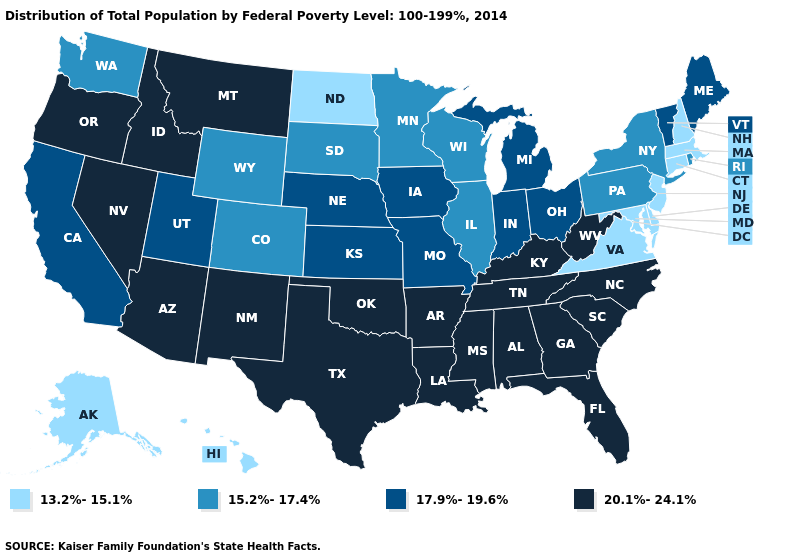What is the value of Illinois?
Short answer required. 15.2%-17.4%. Does Oregon have the highest value in the USA?
Short answer required. Yes. What is the lowest value in the Northeast?
Short answer required. 13.2%-15.1%. Does Florida have a higher value than South Carolina?
Short answer required. No. Does the first symbol in the legend represent the smallest category?
Concise answer only. Yes. What is the highest value in states that border Oregon?
Quick response, please. 20.1%-24.1%. Does Illinois have the lowest value in the USA?
Keep it brief. No. What is the value of Indiana?
Be succinct. 17.9%-19.6%. Name the states that have a value in the range 17.9%-19.6%?
Keep it brief. California, Indiana, Iowa, Kansas, Maine, Michigan, Missouri, Nebraska, Ohio, Utah, Vermont. How many symbols are there in the legend?
Quick response, please. 4. Does Rhode Island have a higher value than Arizona?
Write a very short answer. No. What is the value of Kentucky?
Give a very brief answer. 20.1%-24.1%. How many symbols are there in the legend?
Give a very brief answer. 4. What is the value of Hawaii?
Answer briefly. 13.2%-15.1%. What is the value of North Carolina?
Give a very brief answer. 20.1%-24.1%. 